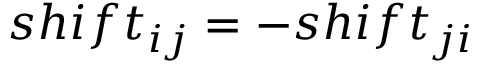<formula> <loc_0><loc_0><loc_500><loc_500>s h i f t _ { i j } = - s h i f t _ { j i }</formula> 